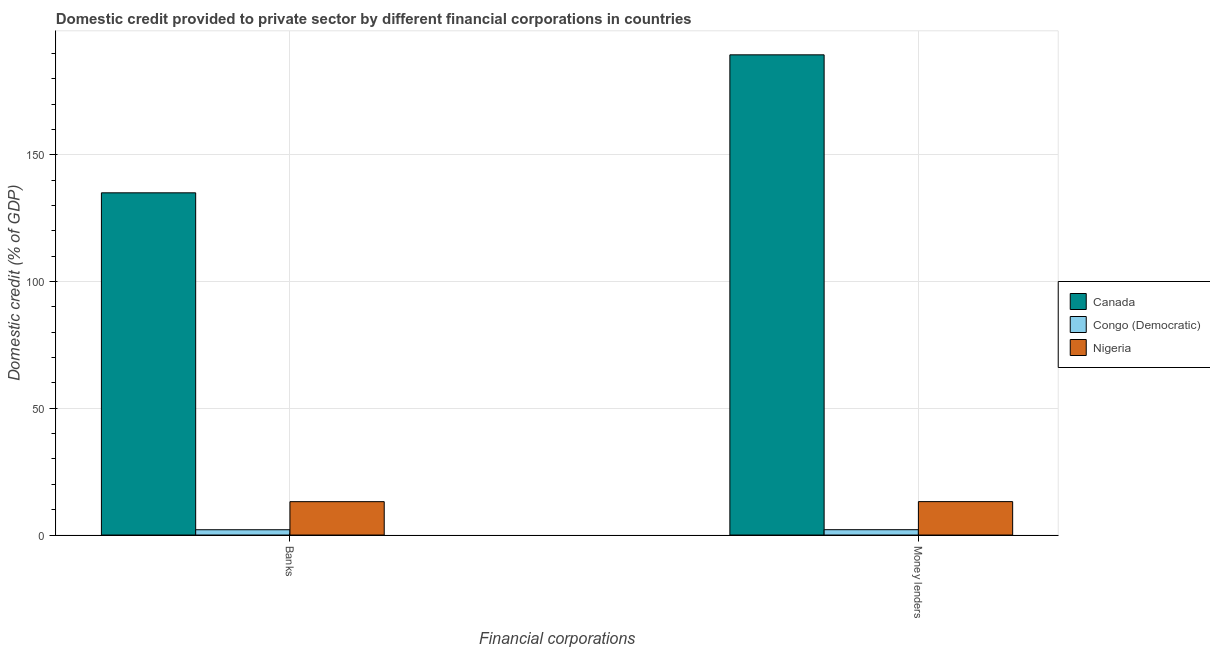How many different coloured bars are there?
Offer a terse response. 3. How many groups of bars are there?
Keep it short and to the point. 2. Are the number of bars on each tick of the X-axis equal?
Your answer should be compact. Yes. How many bars are there on the 2nd tick from the left?
Give a very brief answer. 3. What is the label of the 2nd group of bars from the left?
Offer a terse response. Money lenders. What is the domestic credit provided by money lenders in Congo (Democratic)?
Give a very brief answer. 2.11. Across all countries, what is the maximum domestic credit provided by money lenders?
Make the answer very short. 189.43. Across all countries, what is the minimum domestic credit provided by money lenders?
Make the answer very short. 2.11. In which country was the domestic credit provided by money lenders minimum?
Offer a very short reply. Congo (Democratic). What is the total domestic credit provided by money lenders in the graph?
Keep it short and to the point. 204.71. What is the difference between the domestic credit provided by banks in Canada and that in Congo (Democratic)?
Offer a terse response. 132.9. What is the difference between the domestic credit provided by money lenders in Congo (Democratic) and the domestic credit provided by banks in Canada?
Offer a terse response. -132.89. What is the average domestic credit provided by banks per country?
Your answer should be very brief. 50.08. What is the difference between the domestic credit provided by banks and domestic credit provided by money lenders in Congo (Democratic)?
Keep it short and to the point. -0.01. In how many countries, is the domestic credit provided by banks greater than 10 %?
Provide a short and direct response. 2. What is the ratio of the domestic credit provided by money lenders in Nigeria to that in Congo (Democratic)?
Your answer should be very brief. 6.26. In how many countries, is the domestic credit provided by money lenders greater than the average domestic credit provided by money lenders taken over all countries?
Ensure brevity in your answer.  1. What does the 3rd bar from the left in Money lenders represents?
Offer a terse response. Nigeria. What does the 3rd bar from the right in Money lenders represents?
Your answer should be compact. Canada. How many bars are there?
Give a very brief answer. 6. How many countries are there in the graph?
Keep it short and to the point. 3. Are the values on the major ticks of Y-axis written in scientific E-notation?
Make the answer very short. No. Does the graph contain any zero values?
Offer a very short reply. No. Does the graph contain grids?
Offer a terse response. Yes. How are the legend labels stacked?
Offer a very short reply. Vertical. What is the title of the graph?
Provide a short and direct response. Domestic credit provided to private sector by different financial corporations in countries. Does "Solomon Islands" appear as one of the legend labels in the graph?
Offer a terse response. No. What is the label or title of the X-axis?
Your response must be concise. Financial corporations. What is the label or title of the Y-axis?
Your response must be concise. Domestic credit (% of GDP). What is the Domestic credit (% of GDP) of Canada in Banks?
Give a very brief answer. 134.99. What is the Domestic credit (% of GDP) in Congo (Democratic) in Banks?
Provide a short and direct response. 2.09. What is the Domestic credit (% of GDP) in Nigeria in Banks?
Your answer should be very brief. 13.17. What is the Domestic credit (% of GDP) in Canada in Money lenders?
Your answer should be very brief. 189.43. What is the Domestic credit (% of GDP) in Congo (Democratic) in Money lenders?
Keep it short and to the point. 2.11. What is the Domestic credit (% of GDP) of Nigeria in Money lenders?
Offer a terse response. 13.18. Across all Financial corporations, what is the maximum Domestic credit (% of GDP) in Canada?
Make the answer very short. 189.43. Across all Financial corporations, what is the maximum Domestic credit (% of GDP) in Congo (Democratic)?
Provide a short and direct response. 2.11. Across all Financial corporations, what is the maximum Domestic credit (% of GDP) of Nigeria?
Your answer should be very brief. 13.18. Across all Financial corporations, what is the minimum Domestic credit (% of GDP) in Canada?
Ensure brevity in your answer.  134.99. Across all Financial corporations, what is the minimum Domestic credit (% of GDP) of Congo (Democratic)?
Offer a very short reply. 2.09. Across all Financial corporations, what is the minimum Domestic credit (% of GDP) in Nigeria?
Keep it short and to the point. 13.17. What is the total Domestic credit (% of GDP) of Canada in the graph?
Ensure brevity in your answer.  324.42. What is the total Domestic credit (% of GDP) of Congo (Democratic) in the graph?
Offer a very short reply. 4.2. What is the total Domestic credit (% of GDP) in Nigeria in the graph?
Make the answer very short. 26.35. What is the difference between the Domestic credit (% of GDP) in Canada in Banks and that in Money lenders?
Provide a succinct answer. -54.43. What is the difference between the Domestic credit (% of GDP) of Congo (Democratic) in Banks and that in Money lenders?
Offer a terse response. -0.01. What is the difference between the Domestic credit (% of GDP) in Nigeria in Banks and that in Money lenders?
Make the answer very short. -0.02. What is the difference between the Domestic credit (% of GDP) in Canada in Banks and the Domestic credit (% of GDP) in Congo (Democratic) in Money lenders?
Offer a very short reply. 132.89. What is the difference between the Domestic credit (% of GDP) in Canada in Banks and the Domestic credit (% of GDP) in Nigeria in Money lenders?
Provide a succinct answer. 121.81. What is the difference between the Domestic credit (% of GDP) of Congo (Democratic) in Banks and the Domestic credit (% of GDP) of Nigeria in Money lenders?
Your answer should be compact. -11.09. What is the average Domestic credit (% of GDP) of Canada per Financial corporations?
Offer a very short reply. 162.21. What is the average Domestic credit (% of GDP) of Congo (Democratic) per Financial corporations?
Provide a succinct answer. 2.1. What is the average Domestic credit (% of GDP) of Nigeria per Financial corporations?
Offer a terse response. 13.18. What is the difference between the Domestic credit (% of GDP) of Canada and Domestic credit (% of GDP) of Congo (Democratic) in Banks?
Give a very brief answer. 132.9. What is the difference between the Domestic credit (% of GDP) of Canada and Domestic credit (% of GDP) of Nigeria in Banks?
Provide a short and direct response. 121.82. What is the difference between the Domestic credit (% of GDP) of Congo (Democratic) and Domestic credit (% of GDP) of Nigeria in Banks?
Offer a very short reply. -11.08. What is the difference between the Domestic credit (% of GDP) in Canada and Domestic credit (% of GDP) in Congo (Democratic) in Money lenders?
Provide a succinct answer. 187.32. What is the difference between the Domestic credit (% of GDP) in Canada and Domestic credit (% of GDP) in Nigeria in Money lenders?
Offer a terse response. 176.24. What is the difference between the Domestic credit (% of GDP) of Congo (Democratic) and Domestic credit (% of GDP) of Nigeria in Money lenders?
Your answer should be compact. -11.08. What is the ratio of the Domestic credit (% of GDP) of Canada in Banks to that in Money lenders?
Your answer should be compact. 0.71. What is the difference between the highest and the second highest Domestic credit (% of GDP) in Canada?
Keep it short and to the point. 54.43. What is the difference between the highest and the second highest Domestic credit (% of GDP) of Congo (Democratic)?
Your answer should be very brief. 0.01. What is the difference between the highest and the second highest Domestic credit (% of GDP) of Nigeria?
Your response must be concise. 0.02. What is the difference between the highest and the lowest Domestic credit (% of GDP) in Canada?
Give a very brief answer. 54.43. What is the difference between the highest and the lowest Domestic credit (% of GDP) in Congo (Democratic)?
Your answer should be very brief. 0.01. What is the difference between the highest and the lowest Domestic credit (% of GDP) in Nigeria?
Keep it short and to the point. 0.02. 